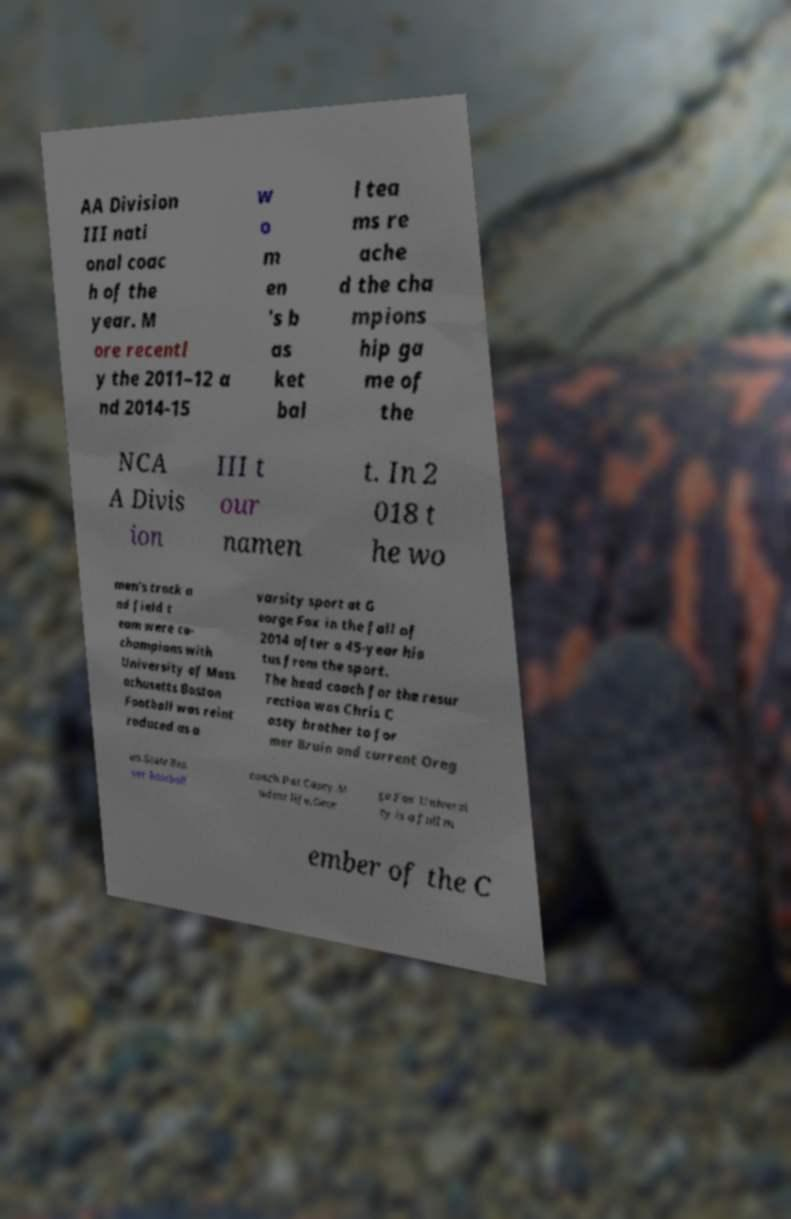There's text embedded in this image that I need extracted. Can you transcribe it verbatim? AA Division III nati onal coac h of the year. M ore recentl y the 2011–12 a nd 2014-15 w o m en 's b as ket bal l tea ms re ache d the cha mpions hip ga me of the NCA A Divis ion III t our namen t. In 2 018 t he wo men's track a nd field t eam were co- champions with University of Mass achusetts Boston Football was reint roduced as a varsity sport at G eorge Fox in the fall of 2014 after a 45-year hia tus from the sport. The head coach for the resur rection was Chris C asey brother to for mer Bruin and current Oreg on State Bea ver baseball coach Pat Casey.St udent life.Geor ge Fox Universi ty is a full m ember of the C 